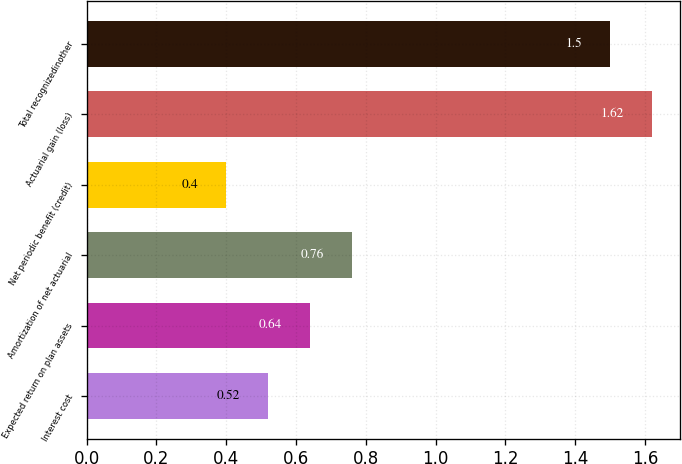<chart> <loc_0><loc_0><loc_500><loc_500><bar_chart><fcel>Interest cost<fcel>Expected return on plan assets<fcel>Amortization of net actuarial<fcel>Net periodic benefit (credit)<fcel>Actuarial gain (loss)<fcel>Total recognizedinother<nl><fcel>0.52<fcel>0.64<fcel>0.76<fcel>0.4<fcel>1.62<fcel>1.5<nl></chart> 